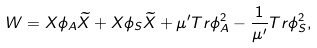<formula> <loc_0><loc_0><loc_500><loc_500>W = X \phi _ { A } \widetilde { X } + X \phi _ { S } \widetilde { X } + \mu ^ { \prime } T r \phi _ { A } ^ { 2 } - \frac { 1 } { \mu ^ { \prime } } T r \phi _ { S } ^ { 2 } ,</formula> 